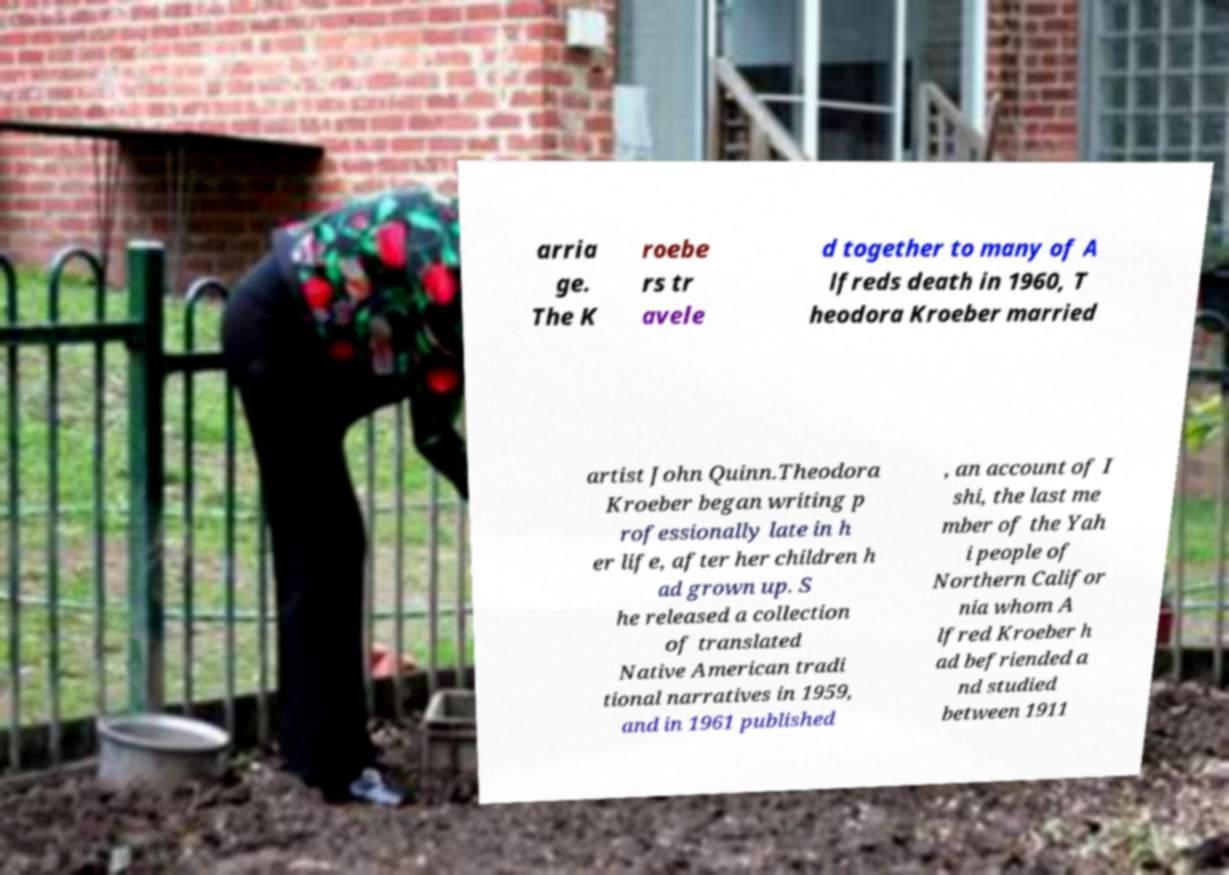What messages or text are displayed in this image? I need them in a readable, typed format. arria ge. The K roebe rs tr avele d together to many of A lfreds death in 1960, T heodora Kroeber married artist John Quinn.Theodora Kroeber began writing p rofessionally late in h er life, after her children h ad grown up. S he released a collection of translated Native American tradi tional narratives in 1959, and in 1961 published , an account of I shi, the last me mber of the Yah i people of Northern Califor nia whom A lfred Kroeber h ad befriended a nd studied between 1911 